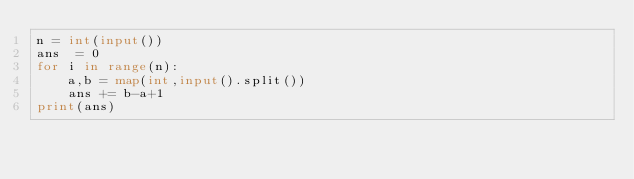Convert code to text. <code><loc_0><loc_0><loc_500><loc_500><_Python_>n = int(input())
ans  = 0
for i in range(n):
    a,b = map(int,input().split())
    ans += b-a+1
print(ans)</code> 